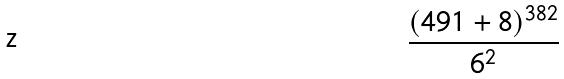<formula> <loc_0><loc_0><loc_500><loc_500>\frac { ( 4 9 1 + 8 ) ^ { 3 8 2 } } { 6 ^ { 2 } }</formula> 